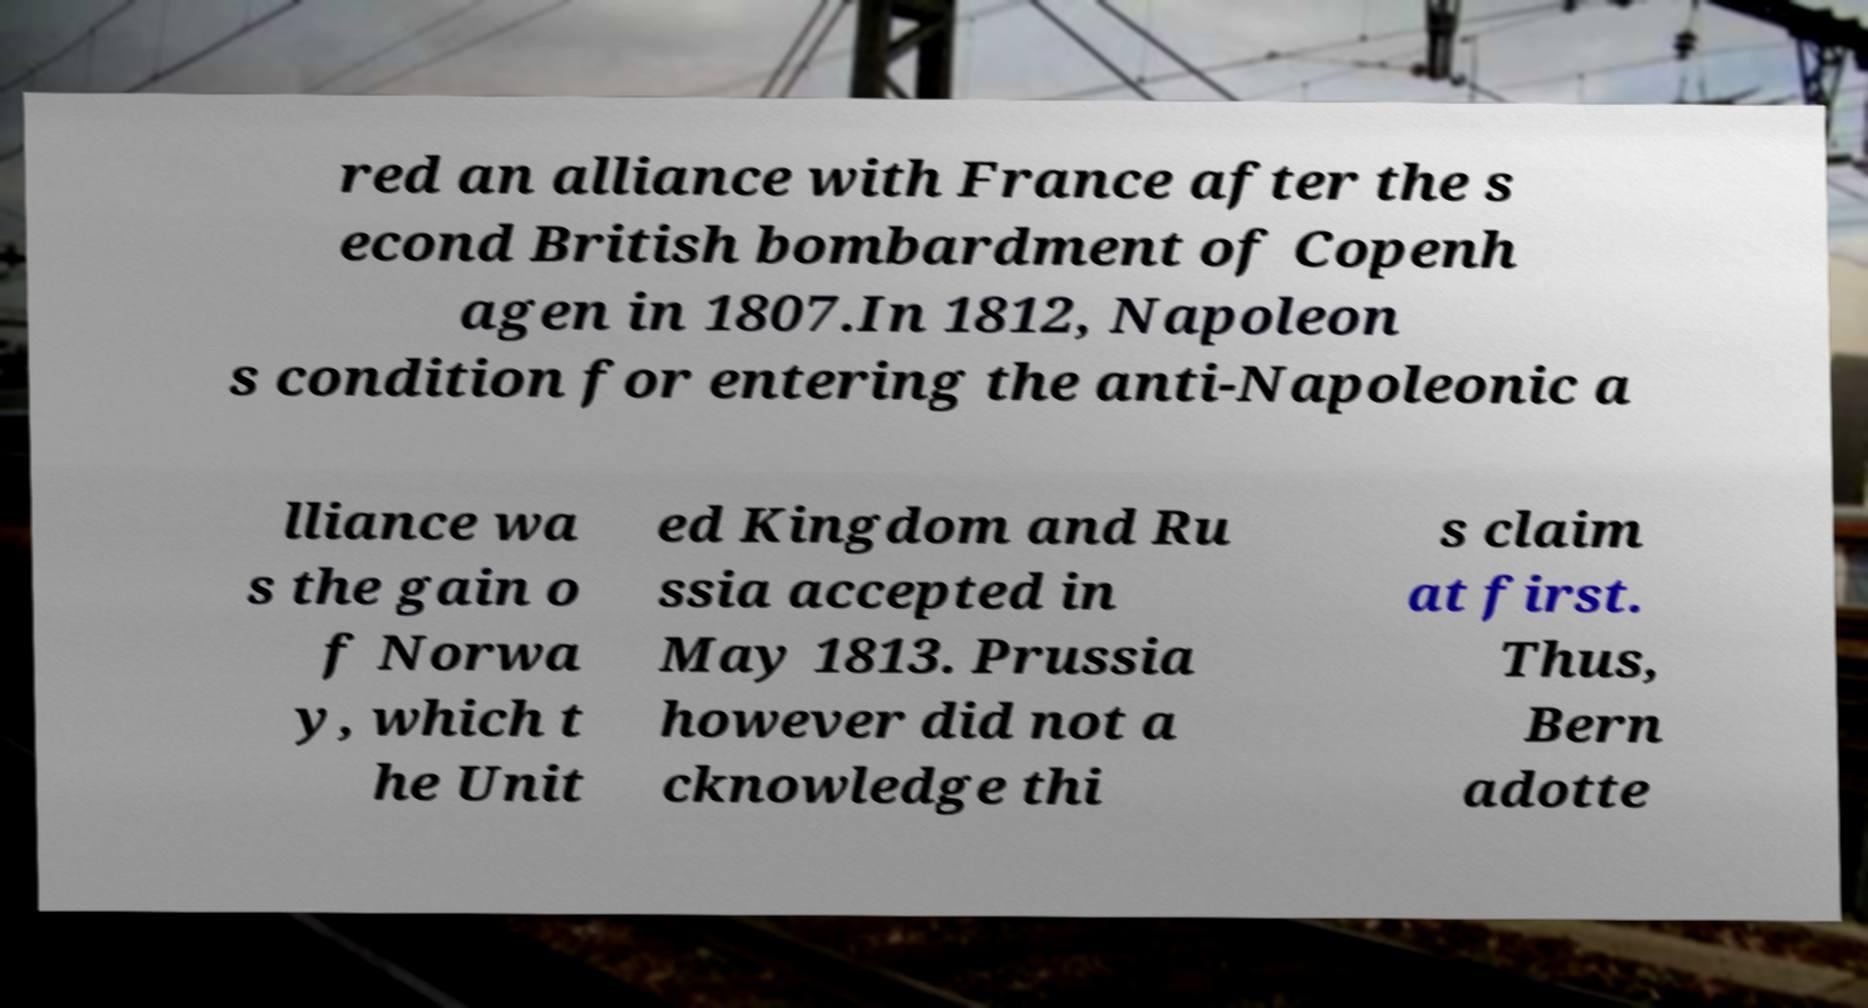There's text embedded in this image that I need extracted. Can you transcribe it verbatim? red an alliance with France after the s econd British bombardment of Copenh agen in 1807.In 1812, Napoleon s condition for entering the anti-Napoleonic a lliance wa s the gain o f Norwa y, which t he Unit ed Kingdom and Ru ssia accepted in May 1813. Prussia however did not a cknowledge thi s claim at first. Thus, Bern adotte 